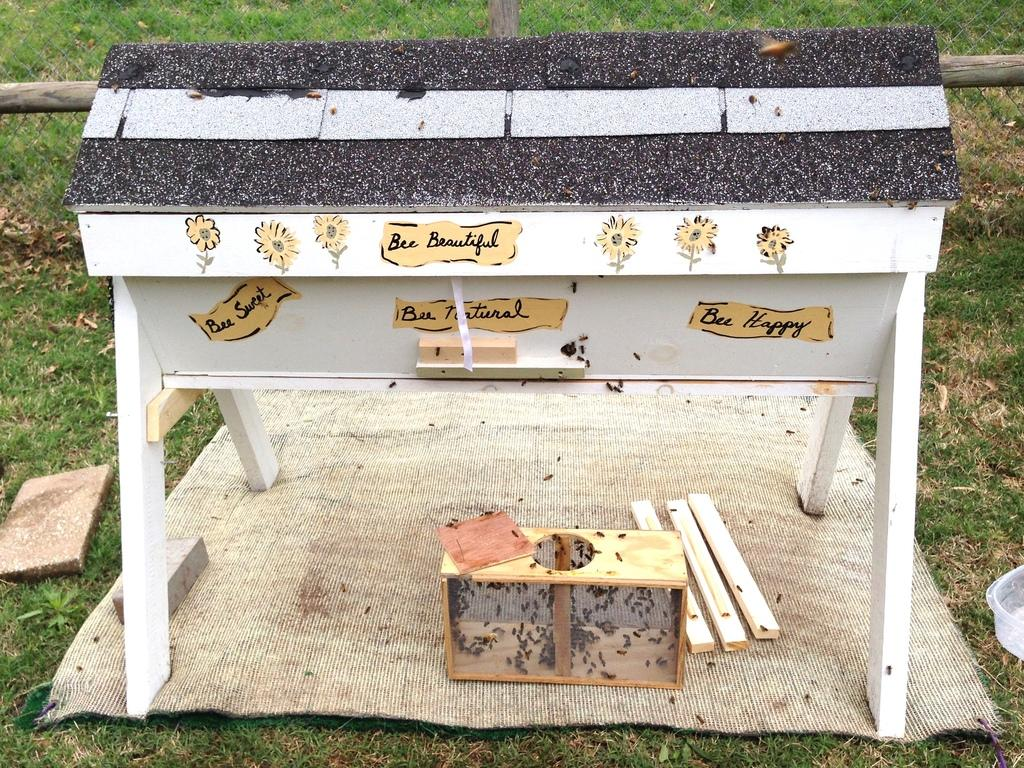<image>
Render a clear and concise summary of the photo. white beehive with painted messages on side such as bee sweet, bee beautiful, and bee happy 